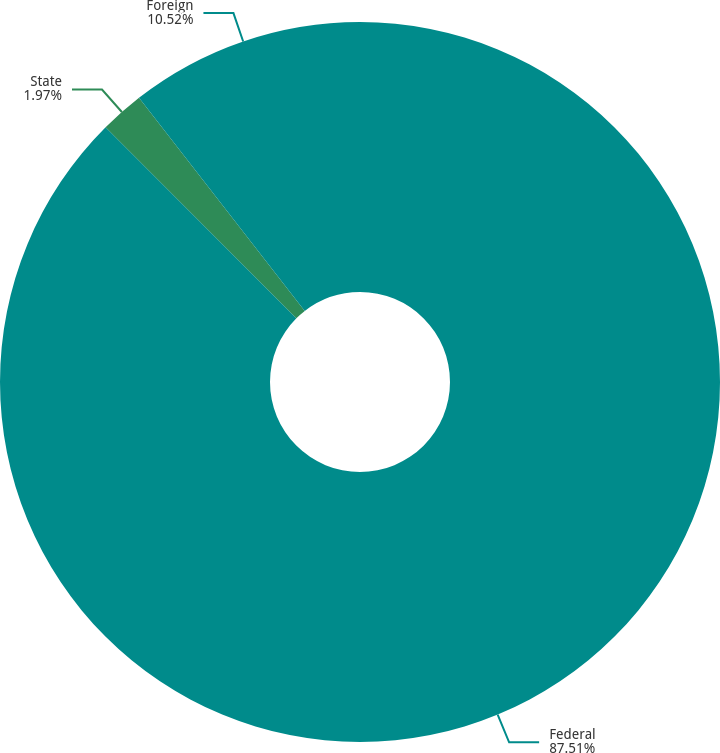Convert chart to OTSL. <chart><loc_0><loc_0><loc_500><loc_500><pie_chart><fcel>Federal<fcel>State<fcel>Foreign<nl><fcel>87.51%<fcel>1.97%<fcel>10.52%<nl></chart> 